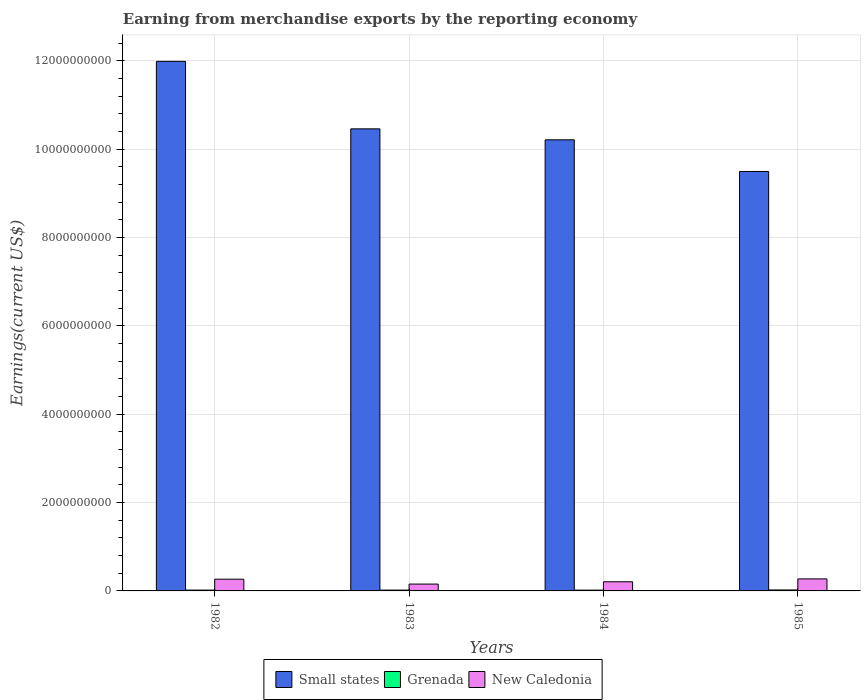How many groups of bars are there?
Offer a terse response. 4. Are the number of bars on each tick of the X-axis equal?
Offer a terse response. Yes. What is the amount earned from merchandise exports in Small states in 1984?
Offer a very short reply. 1.02e+1. Across all years, what is the maximum amount earned from merchandise exports in New Caledonia?
Your answer should be compact. 2.72e+08. Across all years, what is the minimum amount earned from merchandise exports in Grenada?
Your answer should be very brief. 1.77e+07. In which year was the amount earned from merchandise exports in Grenada maximum?
Make the answer very short. 1985. What is the total amount earned from merchandise exports in New Caledonia in the graph?
Provide a short and direct response. 9.00e+08. What is the difference between the amount earned from merchandise exports in New Caledonia in 1982 and that in 1984?
Provide a short and direct response. 5.84e+07. What is the difference between the amount earned from merchandise exports in New Caledonia in 1983 and the amount earned from merchandise exports in Small states in 1985?
Offer a very short reply. -9.34e+09. What is the average amount earned from merchandise exports in Grenada per year?
Provide a short and direct response. 1.93e+07. In the year 1982, what is the difference between the amount earned from merchandise exports in Grenada and amount earned from merchandise exports in New Caledonia?
Make the answer very short. -2.47e+08. What is the ratio of the amount earned from merchandise exports in Small states in 1984 to that in 1985?
Your response must be concise. 1.08. Is the amount earned from merchandise exports in New Caledonia in 1984 less than that in 1985?
Provide a short and direct response. Yes. What is the difference between the highest and the second highest amount earned from merchandise exports in New Caledonia?
Your answer should be very brief. 6.77e+06. What is the difference between the highest and the lowest amount earned from merchandise exports in Grenada?
Make the answer very short. 4.13e+06. In how many years, is the amount earned from merchandise exports in Small states greater than the average amount earned from merchandise exports in Small states taken over all years?
Make the answer very short. 1. What does the 3rd bar from the left in 1983 represents?
Provide a short and direct response. New Caledonia. What does the 2nd bar from the right in 1983 represents?
Provide a succinct answer. Grenada. Is it the case that in every year, the sum of the amount earned from merchandise exports in New Caledonia and amount earned from merchandise exports in Small states is greater than the amount earned from merchandise exports in Grenada?
Offer a terse response. Yes. Are all the bars in the graph horizontal?
Your answer should be very brief. No. Are the values on the major ticks of Y-axis written in scientific E-notation?
Provide a succinct answer. No. Does the graph contain grids?
Offer a very short reply. Yes. How many legend labels are there?
Ensure brevity in your answer.  3. How are the legend labels stacked?
Make the answer very short. Horizontal. What is the title of the graph?
Provide a succinct answer. Earning from merchandise exports by the reporting economy. Does "United Kingdom" appear as one of the legend labels in the graph?
Keep it short and to the point. No. What is the label or title of the Y-axis?
Your answer should be compact. Earnings(current US$). What is the Earnings(current US$) of Small states in 1982?
Keep it short and to the point. 1.20e+1. What is the Earnings(current US$) in Grenada in 1982?
Your response must be concise. 1.88e+07. What is the Earnings(current US$) in New Caledonia in 1982?
Provide a short and direct response. 2.66e+08. What is the Earnings(current US$) in Small states in 1983?
Your answer should be very brief. 1.05e+1. What is the Earnings(current US$) of Grenada in 1983?
Your response must be concise. 1.88e+07. What is the Earnings(current US$) of New Caledonia in 1983?
Offer a very short reply. 1.55e+08. What is the Earnings(current US$) in Small states in 1984?
Make the answer very short. 1.02e+1. What is the Earnings(current US$) of Grenada in 1984?
Ensure brevity in your answer.  1.77e+07. What is the Earnings(current US$) of New Caledonia in 1984?
Your answer should be very brief. 2.07e+08. What is the Earnings(current US$) of Small states in 1985?
Your answer should be compact. 9.50e+09. What is the Earnings(current US$) in Grenada in 1985?
Give a very brief answer. 2.18e+07. What is the Earnings(current US$) of New Caledonia in 1985?
Ensure brevity in your answer.  2.72e+08. Across all years, what is the maximum Earnings(current US$) of Small states?
Your response must be concise. 1.20e+1. Across all years, what is the maximum Earnings(current US$) of Grenada?
Ensure brevity in your answer.  2.18e+07. Across all years, what is the maximum Earnings(current US$) in New Caledonia?
Your answer should be very brief. 2.72e+08. Across all years, what is the minimum Earnings(current US$) in Small states?
Your answer should be compact. 9.50e+09. Across all years, what is the minimum Earnings(current US$) in Grenada?
Offer a terse response. 1.77e+07. Across all years, what is the minimum Earnings(current US$) in New Caledonia?
Ensure brevity in your answer.  1.55e+08. What is the total Earnings(current US$) of Small states in the graph?
Your answer should be compact. 4.22e+1. What is the total Earnings(current US$) of Grenada in the graph?
Provide a succinct answer. 7.72e+07. What is the total Earnings(current US$) of New Caledonia in the graph?
Provide a succinct answer. 9.00e+08. What is the difference between the Earnings(current US$) of Small states in 1982 and that in 1983?
Your answer should be very brief. 1.53e+09. What is the difference between the Earnings(current US$) of Grenada in 1982 and that in 1983?
Your response must be concise. 5.70e+04. What is the difference between the Earnings(current US$) in New Caledonia in 1982 and that in 1983?
Keep it short and to the point. 1.11e+08. What is the difference between the Earnings(current US$) of Small states in 1982 and that in 1984?
Offer a very short reply. 1.78e+09. What is the difference between the Earnings(current US$) in Grenada in 1982 and that in 1984?
Your response must be concise. 1.12e+06. What is the difference between the Earnings(current US$) in New Caledonia in 1982 and that in 1984?
Offer a very short reply. 5.84e+07. What is the difference between the Earnings(current US$) in Small states in 1982 and that in 1985?
Offer a terse response. 2.49e+09. What is the difference between the Earnings(current US$) in Grenada in 1982 and that in 1985?
Ensure brevity in your answer.  -3.01e+06. What is the difference between the Earnings(current US$) in New Caledonia in 1982 and that in 1985?
Keep it short and to the point. -6.77e+06. What is the difference between the Earnings(current US$) of Small states in 1983 and that in 1984?
Ensure brevity in your answer.  2.48e+08. What is the difference between the Earnings(current US$) of Grenada in 1983 and that in 1984?
Give a very brief answer. 1.06e+06. What is the difference between the Earnings(current US$) of New Caledonia in 1983 and that in 1984?
Offer a very short reply. -5.21e+07. What is the difference between the Earnings(current US$) of Small states in 1983 and that in 1985?
Offer a very short reply. 9.65e+08. What is the difference between the Earnings(current US$) in Grenada in 1983 and that in 1985?
Your response must be concise. -3.07e+06. What is the difference between the Earnings(current US$) in New Caledonia in 1983 and that in 1985?
Provide a succinct answer. -1.17e+08. What is the difference between the Earnings(current US$) in Small states in 1984 and that in 1985?
Provide a short and direct response. 7.17e+08. What is the difference between the Earnings(current US$) in Grenada in 1984 and that in 1985?
Ensure brevity in your answer.  -4.13e+06. What is the difference between the Earnings(current US$) of New Caledonia in 1984 and that in 1985?
Provide a short and direct response. -6.52e+07. What is the difference between the Earnings(current US$) in Small states in 1982 and the Earnings(current US$) in Grenada in 1983?
Offer a terse response. 1.20e+1. What is the difference between the Earnings(current US$) of Small states in 1982 and the Earnings(current US$) of New Caledonia in 1983?
Keep it short and to the point. 1.18e+1. What is the difference between the Earnings(current US$) of Grenada in 1982 and the Earnings(current US$) of New Caledonia in 1983?
Provide a succinct answer. -1.36e+08. What is the difference between the Earnings(current US$) in Small states in 1982 and the Earnings(current US$) in Grenada in 1984?
Provide a short and direct response. 1.20e+1. What is the difference between the Earnings(current US$) of Small states in 1982 and the Earnings(current US$) of New Caledonia in 1984?
Ensure brevity in your answer.  1.18e+1. What is the difference between the Earnings(current US$) of Grenada in 1982 and the Earnings(current US$) of New Caledonia in 1984?
Your response must be concise. -1.88e+08. What is the difference between the Earnings(current US$) of Small states in 1982 and the Earnings(current US$) of Grenada in 1985?
Your response must be concise. 1.20e+1. What is the difference between the Earnings(current US$) in Small states in 1982 and the Earnings(current US$) in New Caledonia in 1985?
Keep it short and to the point. 1.17e+1. What is the difference between the Earnings(current US$) of Grenada in 1982 and the Earnings(current US$) of New Caledonia in 1985?
Ensure brevity in your answer.  -2.53e+08. What is the difference between the Earnings(current US$) of Small states in 1983 and the Earnings(current US$) of Grenada in 1984?
Provide a short and direct response. 1.04e+1. What is the difference between the Earnings(current US$) in Small states in 1983 and the Earnings(current US$) in New Caledonia in 1984?
Your answer should be compact. 1.03e+1. What is the difference between the Earnings(current US$) of Grenada in 1983 and the Earnings(current US$) of New Caledonia in 1984?
Give a very brief answer. -1.88e+08. What is the difference between the Earnings(current US$) of Small states in 1983 and the Earnings(current US$) of Grenada in 1985?
Keep it short and to the point. 1.04e+1. What is the difference between the Earnings(current US$) in Small states in 1983 and the Earnings(current US$) in New Caledonia in 1985?
Your answer should be very brief. 1.02e+1. What is the difference between the Earnings(current US$) in Grenada in 1983 and the Earnings(current US$) in New Caledonia in 1985?
Your response must be concise. -2.53e+08. What is the difference between the Earnings(current US$) of Small states in 1984 and the Earnings(current US$) of Grenada in 1985?
Ensure brevity in your answer.  1.02e+1. What is the difference between the Earnings(current US$) of Small states in 1984 and the Earnings(current US$) of New Caledonia in 1985?
Offer a terse response. 9.94e+09. What is the difference between the Earnings(current US$) in Grenada in 1984 and the Earnings(current US$) in New Caledonia in 1985?
Your answer should be very brief. -2.55e+08. What is the average Earnings(current US$) in Small states per year?
Make the answer very short. 1.05e+1. What is the average Earnings(current US$) of Grenada per year?
Give a very brief answer. 1.93e+07. What is the average Earnings(current US$) in New Caledonia per year?
Provide a succinct answer. 2.25e+08. In the year 1982, what is the difference between the Earnings(current US$) in Small states and Earnings(current US$) in Grenada?
Offer a terse response. 1.20e+1. In the year 1982, what is the difference between the Earnings(current US$) in Small states and Earnings(current US$) in New Caledonia?
Your response must be concise. 1.17e+1. In the year 1982, what is the difference between the Earnings(current US$) of Grenada and Earnings(current US$) of New Caledonia?
Make the answer very short. -2.47e+08. In the year 1983, what is the difference between the Earnings(current US$) in Small states and Earnings(current US$) in Grenada?
Your response must be concise. 1.04e+1. In the year 1983, what is the difference between the Earnings(current US$) in Small states and Earnings(current US$) in New Caledonia?
Your answer should be very brief. 1.03e+1. In the year 1983, what is the difference between the Earnings(current US$) of Grenada and Earnings(current US$) of New Caledonia?
Ensure brevity in your answer.  -1.36e+08. In the year 1984, what is the difference between the Earnings(current US$) of Small states and Earnings(current US$) of Grenada?
Offer a terse response. 1.02e+1. In the year 1984, what is the difference between the Earnings(current US$) of Small states and Earnings(current US$) of New Caledonia?
Provide a succinct answer. 1.00e+1. In the year 1984, what is the difference between the Earnings(current US$) of Grenada and Earnings(current US$) of New Caledonia?
Offer a terse response. -1.89e+08. In the year 1985, what is the difference between the Earnings(current US$) in Small states and Earnings(current US$) in Grenada?
Provide a short and direct response. 9.47e+09. In the year 1985, what is the difference between the Earnings(current US$) of Small states and Earnings(current US$) of New Caledonia?
Provide a short and direct response. 9.22e+09. In the year 1985, what is the difference between the Earnings(current US$) of Grenada and Earnings(current US$) of New Caledonia?
Ensure brevity in your answer.  -2.50e+08. What is the ratio of the Earnings(current US$) of Small states in 1982 to that in 1983?
Ensure brevity in your answer.  1.15. What is the ratio of the Earnings(current US$) of Grenada in 1982 to that in 1983?
Your answer should be compact. 1. What is the ratio of the Earnings(current US$) of New Caledonia in 1982 to that in 1983?
Give a very brief answer. 1.71. What is the ratio of the Earnings(current US$) in Small states in 1982 to that in 1984?
Give a very brief answer. 1.17. What is the ratio of the Earnings(current US$) in Grenada in 1982 to that in 1984?
Offer a terse response. 1.06. What is the ratio of the Earnings(current US$) in New Caledonia in 1982 to that in 1984?
Give a very brief answer. 1.28. What is the ratio of the Earnings(current US$) of Small states in 1982 to that in 1985?
Your response must be concise. 1.26. What is the ratio of the Earnings(current US$) of Grenada in 1982 to that in 1985?
Give a very brief answer. 0.86. What is the ratio of the Earnings(current US$) in New Caledonia in 1982 to that in 1985?
Keep it short and to the point. 0.98. What is the ratio of the Earnings(current US$) of Small states in 1983 to that in 1984?
Your answer should be very brief. 1.02. What is the ratio of the Earnings(current US$) in Grenada in 1983 to that in 1984?
Offer a very short reply. 1.06. What is the ratio of the Earnings(current US$) in New Caledonia in 1983 to that in 1984?
Ensure brevity in your answer.  0.75. What is the ratio of the Earnings(current US$) in Small states in 1983 to that in 1985?
Your answer should be very brief. 1.1. What is the ratio of the Earnings(current US$) in Grenada in 1983 to that in 1985?
Your response must be concise. 0.86. What is the ratio of the Earnings(current US$) of New Caledonia in 1983 to that in 1985?
Provide a short and direct response. 0.57. What is the ratio of the Earnings(current US$) of Small states in 1984 to that in 1985?
Give a very brief answer. 1.08. What is the ratio of the Earnings(current US$) in Grenada in 1984 to that in 1985?
Give a very brief answer. 0.81. What is the ratio of the Earnings(current US$) in New Caledonia in 1984 to that in 1985?
Give a very brief answer. 0.76. What is the difference between the highest and the second highest Earnings(current US$) in Small states?
Ensure brevity in your answer.  1.53e+09. What is the difference between the highest and the second highest Earnings(current US$) of Grenada?
Keep it short and to the point. 3.01e+06. What is the difference between the highest and the second highest Earnings(current US$) in New Caledonia?
Your response must be concise. 6.77e+06. What is the difference between the highest and the lowest Earnings(current US$) in Small states?
Keep it short and to the point. 2.49e+09. What is the difference between the highest and the lowest Earnings(current US$) in Grenada?
Provide a succinct answer. 4.13e+06. What is the difference between the highest and the lowest Earnings(current US$) in New Caledonia?
Offer a very short reply. 1.17e+08. 